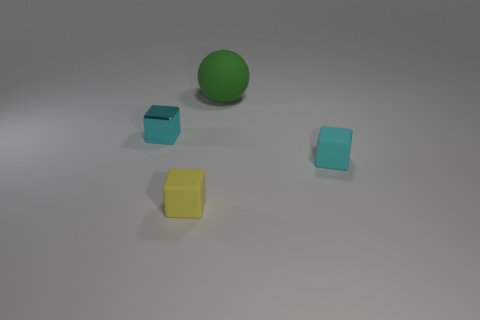Can you describe the lighting and mood of this scene? The scene is lit with a soft, diffused light source that casts gentle shadows on the ground, creating a calm and neutral mood. There's no harsh lighting or dramatic contrasts, which gives the image a simple and straightforward appearance. 